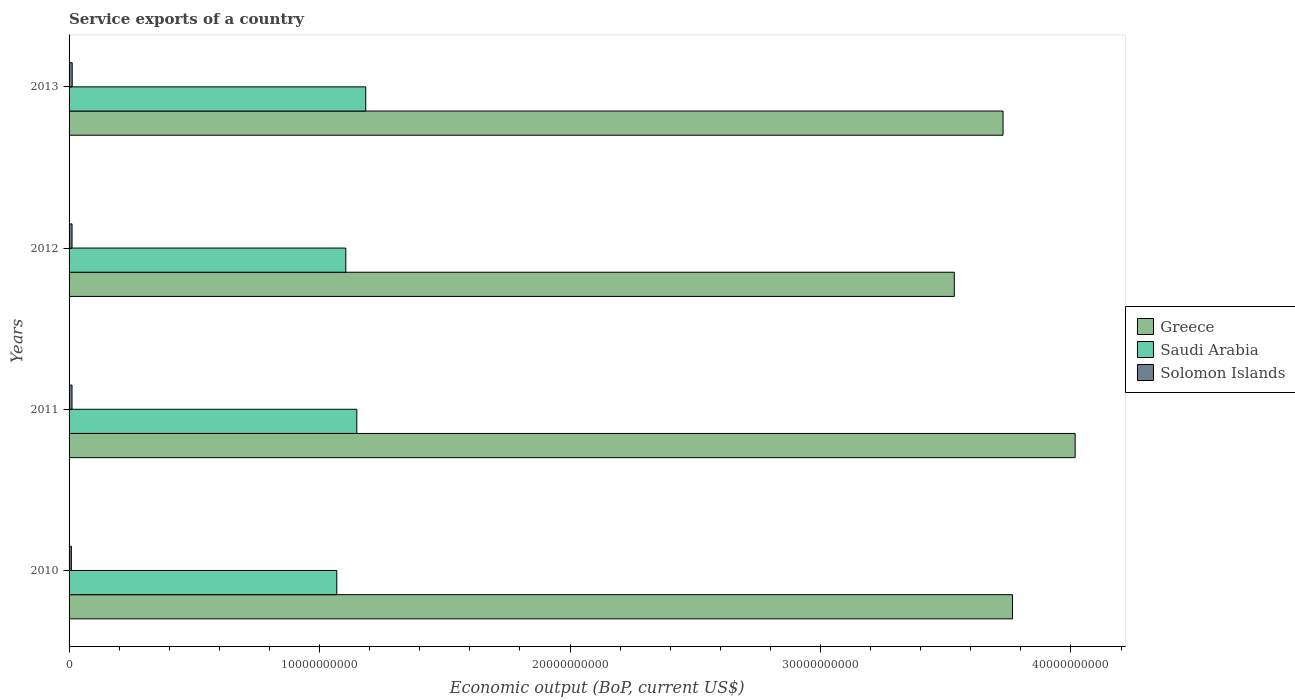How many different coloured bars are there?
Make the answer very short. 3. How many groups of bars are there?
Provide a short and direct response. 4. Are the number of bars per tick equal to the number of legend labels?
Provide a succinct answer. Yes. What is the label of the 3rd group of bars from the top?
Keep it short and to the point. 2011. What is the service exports in Saudi Arabia in 2010?
Offer a very short reply. 1.07e+1. Across all years, what is the maximum service exports in Greece?
Your answer should be very brief. 4.02e+1. Across all years, what is the minimum service exports in Saudi Arabia?
Make the answer very short. 1.07e+1. What is the total service exports in Solomon Islands in the graph?
Ensure brevity in your answer.  4.53e+08. What is the difference between the service exports in Saudi Arabia in 2010 and that in 2012?
Offer a terse response. -3.61e+08. What is the difference between the service exports in Solomon Islands in 2013 and the service exports in Greece in 2012?
Offer a very short reply. -3.52e+1. What is the average service exports in Greece per year?
Make the answer very short. 3.76e+1. In the year 2010, what is the difference between the service exports in Solomon Islands and service exports in Greece?
Offer a very short reply. -3.76e+1. In how many years, is the service exports in Saudi Arabia greater than 34000000000 US$?
Ensure brevity in your answer.  0. What is the ratio of the service exports in Solomon Islands in 2010 to that in 2012?
Give a very brief answer. 0.77. What is the difference between the highest and the second highest service exports in Solomon Islands?
Offer a terse response. 5.72e+06. What is the difference between the highest and the lowest service exports in Saudi Arabia?
Give a very brief answer. 1.16e+09. In how many years, is the service exports in Saudi Arabia greater than the average service exports in Saudi Arabia taken over all years?
Give a very brief answer. 2. What does the 1st bar from the top in 2010 represents?
Ensure brevity in your answer.  Solomon Islands. What does the 3rd bar from the bottom in 2010 represents?
Your response must be concise. Solomon Islands. What is the difference between two consecutive major ticks on the X-axis?
Ensure brevity in your answer.  1.00e+1. Are the values on the major ticks of X-axis written in scientific E-notation?
Ensure brevity in your answer.  No. Does the graph contain any zero values?
Ensure brevity in your answer.  No. Does the graph contain grids?
Your response must be concise. No. Where does the legend appear in the graph?
Your answer should be compact. Center right. How many legend labels are there?
Give a very brief answer. 3. What is the title of the graph?
Your response must be concise. Service exports of a country. Does "India" appear as one of the legend labels in the graph?
Your answer should be compact. No. What is the label or title of the X-axis?
Give a very brief answer. Economic output (BoP, current US$). What is the Economic output (BoP, current US$) in Greece in 2010?
Your answer should be compact. 3.77e+1. What is the Economic output (BoP, current US$) in Saudi Arabia in 2010?
Keep it short and to the point. 1.07e+1. What is the Economic output (BoP, current US$) in Solomon Islands in 2010?
Ensure brevity in your answer.  9.19e+07. What is the Economic output (BoP, current US$) of Greece in 2011?
Ensure brevity in your answer.  4.02e+1. What is the Economic output (BoP, current US$) in Saudi Arabia in 2011?
Offer a very short reply. 1.15e+1. What is the Economic output (BoP, current US$) of Solomon Islands in 2011?
Give a very brief answer. 1.18e+08. What is the Economic output (BoP, current US$) in Greece in 2012?
Offer a terse response. 3.53e+1. What is the Economic output (BoP, current US$) of Saudi Arabia in 2012?
Your answer should be very brief. 1.10e+1. What is the Economic output (BoP, current US$) of Solomon Islands in 2012?
Your response must be concise. 1.19e+08. What is the Economic output (BoP, current US$) in Greece in 2013?
Offer a terse response. 3.73e+1. What is the Economic output (BoP, current US$) in Saudi Arabia in 2013?
Give a very brief answer. 1.18e+1. What is the Economic output (BoP, current US$) in Solomon Islands in 2013?
Ensure brevity in your answer.  1.25e+08. Across all years, what is the maximum Economic output (BoP, current US$) in Greece?
Offer a terse response. 4.02e+1. Across all years, what is the maximum Economic output (BoP, current US$) in Saudi Arabia?
Your response must be concise. 1.18e+1. Across all years, what is the maximum Economic output (BoP, current US$) of Solomon Islands?
Provide a succinct answer. 1.25e+08. Across all years, what is the minimum Economic output (BoP, current US$) of Greece?
Keep it short and to the point. 3.53e+1. Across all years, what is the minimum Economic output (BoP, current US$) of Saudi Arabia?
Your answer should be compact. 1.07e+1. Across all years, what is the minimum Economic output (BoP, current US$) in Solomon Islands?
Offer a very short reply. 9.19e+07. What is the total Economic output (BoP, current US$) in Greece in the graph?
Your answer should be very brief. 1.50e+11. What is the total Economic output (BoP, current US$) in Saudi Arabia in the graph?
Offer a terse response. 4.51e+1. What is the total Economic output (BoP, current US$) of Solomon Islands in the graph?
Keep it short and to the point. 4.53e+08. What is the difference between the Economic output (BoP, current US$) of Greece in 2010 and that in 2011?
Offer a terse response. -2.50e+09. What is the difference between the Economic output (BoP, current US$) in Saudi Arabia in 2010 and that in 2011?
Your answer should be very brief. -8.00e+08. What is the difference between the Economic output (BoP, current US$) of Solomon Islands in 2010 and that in 2011?
Offer a very short reply. -2.56e+07. What is the difference between the Economic output (BoP, current US$) in Greece in 2010 and that in 2012?
Ensure brevity in your answer.  2.32e+09. What is the difference between the Economic output (BoP, current US$) in Saudi Arabia in 2010 and that in 2012?
Provide a short and direct response. -3.61e+08. What is the difference between the Economic output (BoP, current US$) of Solomon Islands in 2010 and that in 2012?
Provide a succinct answer. -2.72e+07. What is the difference between the Economic output (BoP, current US$) in Greece in 2010 and that in 2013?
Give a very brief answer. 3.77e+08. What is the difference between the Economic output (BoP, current US$) in Saudi Arabia in 2010 and that in 2013?
Provide a short and direct response. -1.16e+09. What is the difference between the Economic output (BoP, current US$) of Solomon Islands in 2010 and that in 2013?
Provide a succinct answer. -3.29e+07. What is the difference between the Economic output (BoP, current US$) of Greece in 2011 and that in 2012?
Provide a short and direct response. 4.83e+09. What is the difference between the Economic output (BoP, current US$) of Saudi Arabia in 2011 and that in 2012?
Make the answer very short. 4.39e+08. What is the difference between the Economic output (BoP, current US$) of Solomon Islands in 2011 and that in 2012?
Provide a short and direct response. -1.62e+06. What is the difference between the Economic output (BoP, current US$) of Greece in 2011 and that in 2013?
Your answer should be very brief. 2.88e+09. What is the difference between the Economic output (BoP, current US$) in Saudi Arabia in 2011 and that in 2013?
Keep it short and to the point. -3.56e+08. What is the difference between the Economic output (BoP, current US$) in Solomon Islands in 2011 and that in 2013?
Your answer should be compact. -7.33e+06. What is the difference between the Economic output (BoP, current US$) of Greece in 2012 and that in 2013?
Keep it short and to the point. -1.95e+09. What is the difference between the Economic output (BoP, current US$) in Saudi Arabia in 2012 and that in 2013?
Your answer should be very brief. -7.95e+08. What is the difference between the Economic output (BoP, current US$) of Solomon Islands in 2012 and that in 2013?
Your answer should be very brief. -5.72e+06. What is the difference between the Economic output (BoP, current US$) in Greece in 2010 and the Economic output (BoP, current US$) in Saudi Arabia in 2011?
Ensure brevity in your answer.  2.62e+1. What is the difference between the Economic output (BoP, current US$) in Greece in 2010 and the Economic output (BoP, current US$) in Solomon Islands in 2011?
Your answer should be very brief. 3.75e+1. What is the difference between the Economic output (BoP, current US$) of Saudi Arabia in 2010 and the Economic output (BoP, current US$) of Solomon Islands in 2011?
Your answer should be very brief. 1.06e+1. What is the difference between the Economic output (BoP, current US$) in Greece in 2010 and the Economic output (BoP, current US$) in Saudi Arabia in 2012?
Your answer should be compact. 2.66e+1. What is the difference between the Economic output (BoP, current US$) of Greece in 2010 and the Economic output (BoP, current US$) of Solomon Islands in 2012?
Make the answer very short. 3.75e+1. What is the difference between the Economic output (BoP, current US$) of Saudi Arabia in 2010 and the Economic output (BoP, current US$) of Solomon Islands in 2012?
Ensure brevity in your answer.  1.06e+1. What is the difference between the Economic output (BoP, current US$) of Greece in 2010 and the Economic output (BoP, current US$) of Saudi Arabia in 2013?
Give a very brief answer. 2.58e+1. What is the difference between the Economic output (BoP, current US$) of Greece in 2010 and the Economic output (BoP, current US$) of Solomon Islands in 2013?
Ensure brevity in your answer.  3.75e+1. What is the difference between the Economic output (BoP, current US$) of Saudi Arabia in 2010 and the Economic output (BoP, current US$) of Solomon Islands in 2013?
Offer a very short reply. 1.06e+1. What is the difference between the Economic output (BoP, current US$) of Greece in 2011 and the Economic output (BoP, current US$) of Saudi Arabia in 2012?
Your response must be concise. 2.91e+1. What is the difference between the Economic output (BoP, current US$) in Greece in 2011 and the Economic output (BoP, current US$) in Solomon Islands in 2012?
Ensure brevity in your answer.  4.00e+1. What is the difference between the Economic output (BoP, current US$) of Saudi Arabia in 2011 and the Economic output (BoP, current US$) of Solomon Islands in 2012?
Ensure brevity in your answer.  1.14e+1. What is the difference between the Economic output (BoP, current US$) in Greece in 2011 and the Economic output (BoP, current US$) in Saudi Arabia in 2013?
Offer a terse response. 2.83e+1. What is the difference between the Economic output (BoP, current US$) in Greece in 2011 and the Economic output (BoP, current US$) in Solomon Islands in 2013?
Your answer should be very brief. 4.00e+1. What is the difference between the Economic output (BoP, current US$) in Saudi Arabia in 2011 and the Economic output (BoP, current US$) in Solomon Islands in 2013?
Offer a terse response. 1.14e+1. What is the difference between the Economic output (BoP, current US$) of Greece in 2012 and the Economic output (BoP, current US$) of Saudi Arabia in 2013?
Your response must be concise. 2.35e+1. What is the difference between the Economic output (BoP, current US$) in Greece in 2012 and the Economic output (BoP, current US$) in Solomon Islands in 2013?
Offer a terse response. 3.52e+1. What is the difference between the Economic output (BoP, current US$) of Saudi Arabia in 2012 and the Economic output (BoP, current US$) of Solomon Islands in 2013?
Give a very brief answer. 1.09e+1. What is the average Economic output (BoP, current US$) in Greece per year?
Give a very brief answer. 3.76e+1. What is the average Economic output (BoP, current US$) of Saudi Arabia per year?
Your answer should be compact. 1.13e+1. What is the average Economic output (BoP, current US$) in Solomon Islands per year?
Keep it short and to the point. 1.13e+08. In the year 2010, what is the difference between the Economic output (BoP, current US$) in Greece and Economic output (BoP, current US$) in Saudi Arabia?
Your response must be concise. 2.70e+1. In the year 2010, what is the difference between the Economic output (BoP, current US$) in Greece and Economic output (BoP, current US$) in Solomon Islands?
Provide a succinct answer. 3.76e+1. In the year 2010, what is the difference between the Economic output (BoP, current US$) of Saudi Arabia and Economic output (BoP, current US$) of Solomon Islands?
Ensure brevity in your answer.  1.06e+1. In the year 2011, what is the difference between the Economic output (BoP, current US$) in Greece and Economic output (BoP, current US$) in Saudi Arabia?
Make the answer very short. 2.87e+1. In the year 2011, what is the difference between the Economic output (BoP, current US$) in Greece and Economic output (BoP, current US$) in Solomon Islands?
Your answer should be compact. 4.01e+1. In the year 2011, what is the difference between the Economic output (BoP, current US$) of Saudi Arabia and Economic output (BoP, current US$) of Solomon Islands?
Provide a succinct answer. 1.14e+1. In the year 2012, what is the difference between the Economic output (BoP, current US$) of Greece and Economic output (BoP, current US$) of Saudi Arabia?
Your answer should be compact. 2.43e+1. In the year 2012, what is the difference between the Economic output (BoP, current US$) in Greece and Economic output (BoP, current US$) in Solomon Islands?
Make the answer very short. 3.52e+1. In the year 2012, what is the difference between the Economic output (BoP, current US$) in Saudi Arabia and Economic output (BoP, current US$) in Solomon Islands?
Ensure brevity in your answer.  1.09e+1. In the year 2013, what is the difference between the Economic output (BoP, current US$) in Greece and Economic output (BoP, current US$) in Saudi Arabia?
Your answer should be compact. 2.54e+1. In the year 2013, what is the difference between the Economic output (BoP, current US$) in Greece and Economic output (BoP, current US$) in Solomon Islands?
Make the answer very short. 3.72e+1. In the year 2013, what is the difference between the Economic output (BoP, current US$) of Saudi Arabia and Economic output (BoP, current US$) of Solomon Islands?
Make the answer very short. 1.17e+1. What is the ratio of the Economic output (BoP, current US$) in Greece in 2010 to that in 2011?
Make the answer very short. 0.94. What is the ratio of the Economic output (BoP, current US$) in Saudi Arabia in 2010 to that in 2011?
Provide a short and direct response. 0.93. What is the ratio of the Economic output (BoP, current US$) in Solomon Islands in 2010 to that in 2011?
Offer a terse response. 0.78. What is the ratio of the Economic output (BoP, current US$) of Greece in 2010 to that in 2012?
Offer a terse response. 1.07. What is the ratio of the Economic output (BoP, current US$) of Saudi Arabia in 2010 to that in 2012?
Your answer should be compact. 0.97. What is the ratio of the Economic output (BoP, current US$) in Solomon Islands in 2010 to that in 2012?
Your answer should be very brief. 0.77. What is the ratio of the Economic output (BoP, current US$) of Greece in 2010 to that in 2013?
Ensure brevity in your answer.  1.01. What is the ratio of the Economic output (BoP, current US$) of Saudi Arabia in 2010 to that in 2013?
Give a very brief answer. 0.9. What is the ratio of the Economic output (BoP, current US$) in Solomon Islands in 2010 to that in 2013?
Your answer should be compact. 0.74. What is the ratio of the Economic output (BoP, current US$) of Greece in 2011 to that in 2012?
Make the answer very short. 1.14. What is the ratio of the Economic output (BoP, current US$) in Saudi Arabia in 2011 to that in 2012?
Offer a terse response. 1.04. What is the ratio of the Economic output (BoP, current US$) in Solomon Islands in 2011 to that in 2012?
Offer a terse response. 0.99. What is the ratio of the Economic output (BoP, current US$) in Greece in 2011 to that in 2013?
Your response must be concise. 1.08. What is the ratio of the Economic output (BoP, current US$) in Saudi Arabia in 2011 to that in 2013?
Your answer should be very brief. 0.97. What is the ratio of the Economic output (BoP, current US$) in Solomon Islands in 2011 to that in 2013?
Keep it short and to the point. 0.94. What is the ratio of the Economic output (BoP, current US$) of Greece in 2012 to that in 2013?
Provide a short and direct response. 0.95. What is the ratio of the Economic output (BoP, current US$) in Saudi Arabia in 2012 to that in 2013?
Provide a succinct answer. 0.93. What is the ratio of the Economic output (BoP, current US$) of Solomon Islands in 2012 to that in 2013?
Ensure brevity in your answer.  0.95. What is the difference between the highest and the second highest Economic output (BoP, current US$) of Greece?
Provide a short and direct response. 2.50e+09. What is the difference between the highest and the second highest Economic output (BoP, current US$) in Saudi Arabia?
Your answer should be very brief. 3.56e+08. What is the difference between the highest and the second highest Economic output (BoP, current US$) of Solomon Islands?
Ensure brevity in your answer.  5.72e+06. What is the difference between the highest and the lowest Economic output (BoP, current US$) of Greece?
Offer a very short reply. 4.83e+09. What is the difference between the highest and the lowest Economic output (BoP, current US$) in Saudi Arabia?
Keep it short and to the point. 1.16e+09. What is the difference between the highest and the lowest Economic output (BoP, current US$) of Solomon Islands?
Your answer should be very brief. 3.29e+07. 